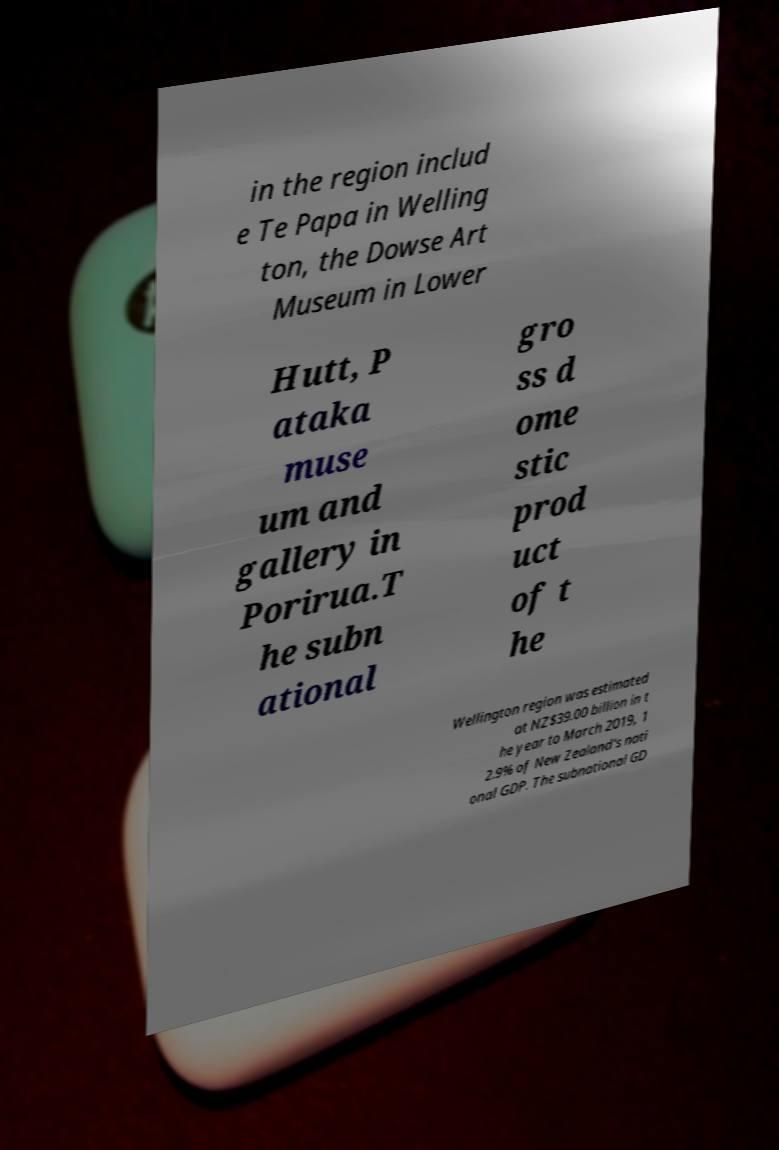There's text embedded in this image that I need extracted. Can you transcribe it verbatim? in the region includ e Te Papa in Welling ton, the Dowse Art Museum in Lower Hutt, P ataka muse um and gallery in Porirua.T he subn ational gro ss d ome stic prod uct of t he Wellington region was estimated at NZ$39.00 billion in t he year to March 2019, 1 2.9% of New Zealand's nati onal GDP. The subnational GD 